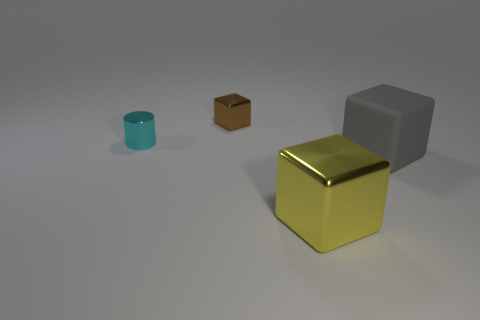How many other cubes have the same size as the gray block?
Give a very brief answer. 1. Does the big object right of the yellow cube have the same shape as the thing that is to the left of the brown shiny block?
Ensure brevity in your answer.  No. What material is the gray cube in front of the metal cube to the left of the object that is in front of the big matte block?
Provide a short and direct response. Rubber. What shape is the gray object that is the same size as the yellow metal thing?
Provide a succinct answer. Cube. What size is the cyan thing?
Offer a very short reply. Small. Is the material of the small brown block the same as the gray object?
Give a very brief answer. No. How many big yellow metal things are to the right of the metallic block that is behind the object that is in front of the matte block?
Your response must be concise. 1. There is a big thing that is behind the large yellow cube; what shape is it?
Your response must be concise. Cube. How many other things are made of the same material as the big yellow thing?
Keep it short and to the point. 2. Is the number of gray matte objects behind the large gray matte block less than the number of objects that are in front of the small cyan metallic object?
Keep it short and to the point. Yes. 